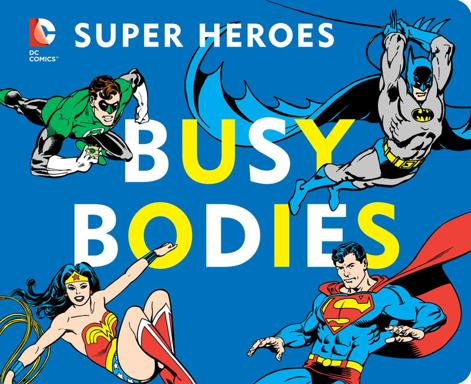Which characters are depicted on the image and what might their inclusion suggest about the audience of the product? The image includes Batman, Superman, Wonder Woman, and Robin. Their inclusion suggests this product is targeted at fans of classic DC comics, likely appealing to both long-time enthusiasts and younger audiences attracted to timeless superhero themes. 